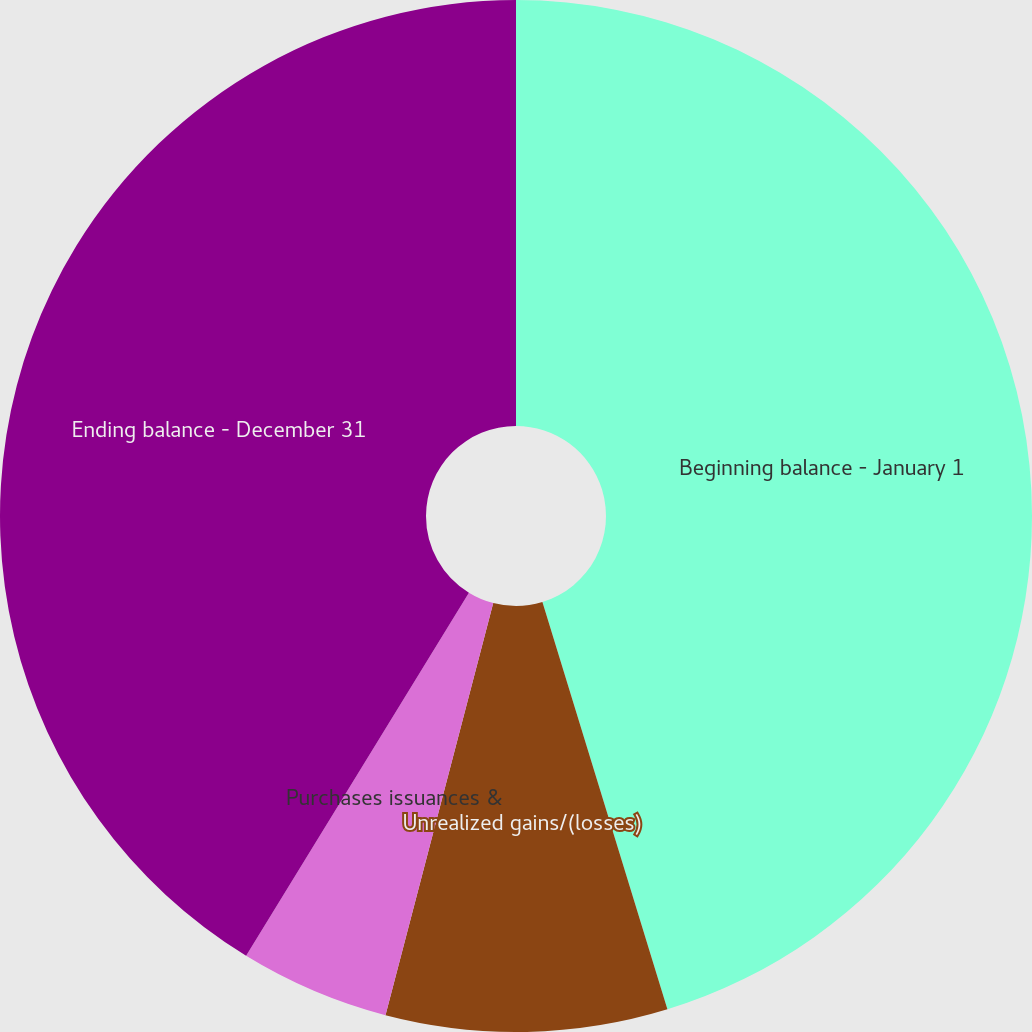Convert chart. <chart><loc_0><loc_0><loc_500><loc_500><pie_chart><fcel>Beginning balance - January 1<fcel>Unrealized gains/(losses)<fcel>Purchases issuances &<fcel>Ending balance - December 31<nl><fcel>45.26%<fcel>8.81%<fcel>4.69%<fcel>41.24%<nl></chart> 